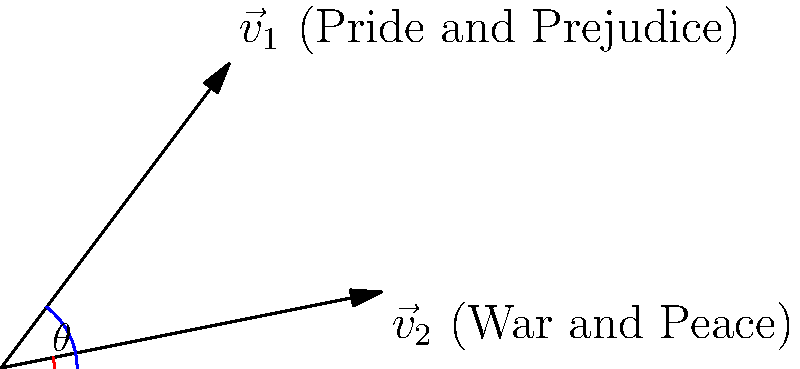Two classic literary works, "Pride and Prejudice" and "War and Peace," are represented by vectors $\vec{v}_1 = (3, 4)$ and $\vec{v}_2 = (5, 1)$ respectively. Calculate the angle $\theta$ between these vectors, considering how the themes and historical contexts of these works might intersect. Express your answer in degrees, rounded to the nearest whole number. Let's approach this step-by-step, keeping in mind the literary significance:

1) The formula for the angle between two vectors is:
   $$\cos \theta = \frac{\vec{v}_1 \cdot \vec{v}_2}{|\vec{v}_1| |\vec{v}_2|}$$

2) Calculate the dot product $\vec{v}_1 \cdot \vec{v}_2$:
   $$(3 \times 5) + (4 \times 1) = 15 + 4 = 19$$

3) Calculate the magnitudes:
   $|\vec{v}_1| = \sqrt{3^2 + 4^2} = \sqrt{25} = 5$
   $|\vec{v}_2| = \sqrt{5^2 + 1^2} = \sqrt{26}$

4) Substitute into the formula:
   $$\cos \theta = \frac{19}{5\sqrt{26}}$$

5) Take the inverse cosine (arccos) of both sides:
   $$\theta = \arccos(\frac{19}{5\sqrt{26}})$$

6) Calculate and convert to degrees:
   $$\theta \approx 0.5095 \text{ radians} \approx 29.2^\circ$$

7) Rounding to the nearest whole number:
   $$\theta \approx 29^\circ$$

This angle might symbolize the divergence in themes and historical contexts between Jane Austen's "Pride and Prejudice" (early 19th century England) and Leo Tolstoy's "War and Peace" (Napoleonic era Russia), while also acknowledging some common ground in their exploration of societal norms and human relationships.
Answer: 29° 